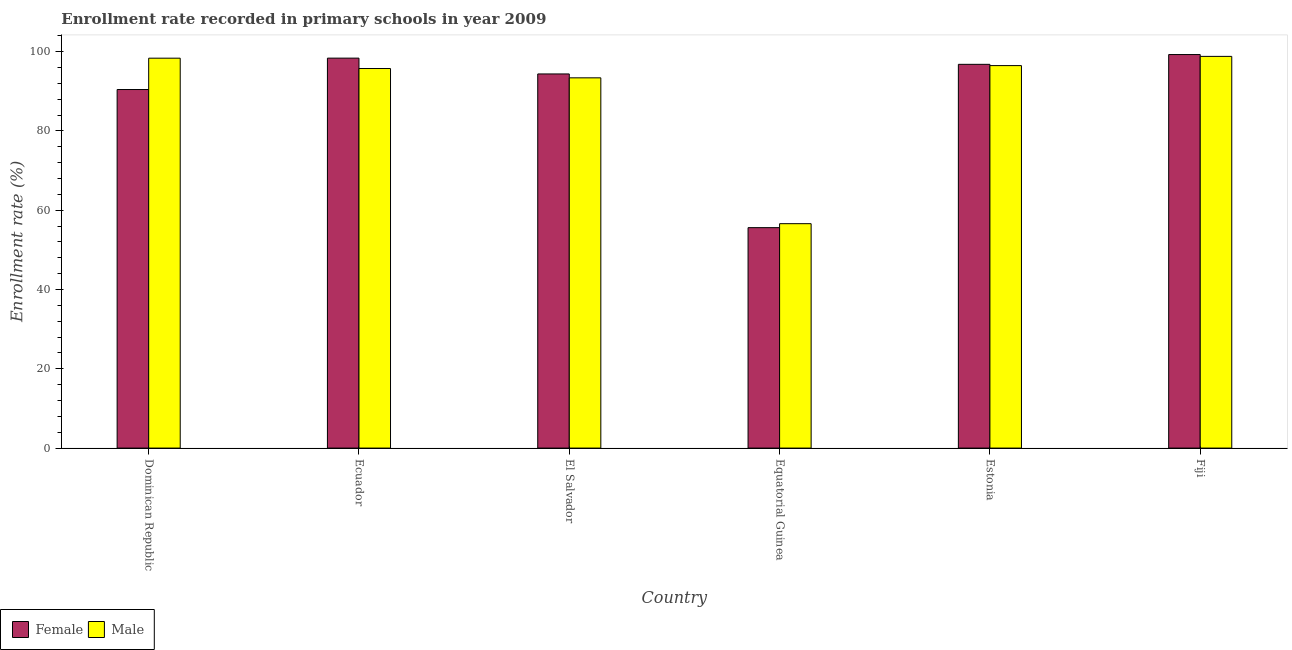How many different coloured bars are there?
Give a very brief answer. 2. How many bars are there on the 4th tick from the right?
Your answer should be compact. 2. What is the label of the 4th group of bars from the left?
Keep it short and to the point. Equatorial Guinea. What is the enrollment rate of male students in Dominican Republic?
Ensure brevity in your answer.  98.36. Across all countries, what is the maximum enrollment rate of male students?
Provide a succinct answer. 98.82. Across all countries, what is the minimum enrollment rate of female students?
Provide a short and direct response. 55.61. In which country was the enrollment rate of male students maximum?
Your response must be concise. Fiji. In which country was the enrollment rate of male students minimum?
Make the answer very short. Equatorial Guinea. What is the total enrollment rate of male students in the graph?
Give a very brief answer. 539.43. What is the difference between the enrollment rate of female students in Dominican Republic and that in Estonia?
Your response must be concise. -6.35. What is the difference between the enrollment rate of male students in El Salvador and the enrollment rate of female students in Dominican Republic?
Make the answer very short. 2.95. What is the average enrollment rate of male students per country?
Provide a succinct answer. 89.9. What is the difference between the enrollment rate of female students and enrollment rate of male students in El Salvador?
Offer a terse response. 0.98. What is the ratio of the enrollment rate of female students in Dominican Republic to that in Fiji?
Give a very brief answer. 0.91. Is the difference between the enrollment rate of female students in Ecuador and Fiji greater than the difference between the enrollment rate of male students in Ecuador and Fiji?
Your answer should be compact. Yes. What is the difference between the highest and the second highest enrollment rate of female students?
Offer a terse response. 0.9. What is the difference between the highest and the lowest enrollment rate of male students?
Your answer should be compact. 42.2. Is the sum of the enrollment rate of male students in Ecuador and Estonia greater than the maximum enrollment rate of female students across all countries?
Your response must be concise. Yes. What does the 1st bar from the left in Ecuador represents?
Your answer should be compact. Female. What does the 1st bar from the right in Estonia represents?
Your answer should be very brief. Male. How many bars are there?
Your answer should be compact. 12. What is the difference between two consecutive major ticks on the Y-axis?
Your answer should be compact. 20. Does the graph contain grids?
Make the answer very short. No. How are the legend labels stacked?
Your answer should be compact. Horizontal. What is the title of the graph?
Ensure brevity in your answer.  Enrollment rate recorded in primary schools in year 2009. What is the label or title of the Y-axis?
Provide a short and direct response. Enrollment rate (%). What is the Enrollment rate (%) in Female in Dominican Republic?
Offer a very short reply. 90.45. What is the Enrollment rate (%) in Male in Dominican Republic?
Make the answer very short. 98.36. What is the Enrollment rate (%) of Female in Ecuador?
Your answer should be compact. 98.37. What is the Enrollment rate (%) of Male in Ecuador?
Keep it short and to the point. 95.75. What is the Enrollment rate (%) of Female in El Salvador?
Give a very brief answer. 94.38. What is the Enrollment rate (%) of Male in El Salvador?
Offer a very short reply. 93.4. What is the Enrollment rate (%) in Female in Equatorial Guinea?
Keep it short and to the point. 55.61. What is the Enrollment rate (%) in Male in Equatorial Guinea?
Provide a short and direct response. 56.61. What is the Enrollment rate (%) of Female in Estonia?
Keep it short and to the point. 96.81. What is the Enrollment rate (%) of Male in Estonia?
Provide a succinct answer. 96.49. What is the Enrollment rate (%) of Female in Fiji?
Offer a terse response. 99.28. What is the Enrollment rate (%) of Male in Fiji?
Your answer should be compact. 98.82. Across all countries, what is the maximum Enrollment rate (%) in Female?
Your answer should be compact. 99.28. Across all countries, what is the maximum Enrollment rate (%) in Male?
Keep it short and to the point. 98.82. Across all countries, what is the minimum Enrollment rate (%) in Female?
Offer a terse response. 55.61. Across all countries, what is the minimum Enrollment rate (%) in Male?
Make the answer very short. 56.61. What is the total Enrollment rate (%) of Female in the graph?
Offer a very short reply. 534.9. What is the total Enrollment rate (%) in Male in the graph?
Provide a succinct answer. 539.43. What is the difference between the Enrollment rate (%) of Female in Dominican Republic and that in Ecuador?
Give a very brief answer. -7.92. What is the difference between the Enrollment rate (%) of Male in Dominican Republic and that in Ecuador?
Your response must be concise. 2.61. What is the difference between the Enrollment rate (%) in Female in Dominican Republic and that in El Salvador?
Give a very brief answer. -3.93. What is the difference between the Enrollment rate (%) in Male in Dominican Republic and that in El Salvador?
Give a very brief answer. 4.96. What is the difference between the Enrollment rate (%) of Female in Dominican Republic and that in Equatorial Guinea?
Provide a short and direct response. 34.85. What is the difference between the Enrollment rate (%) in Male in Dominican Republic and that in Equatorial Guinea?
Your response must be concise. 41.75. What is the difference between the Enrollment rate (%) in Female in Dominican Republic and that in Estonia?
Your answer should be very brief. -6.35. What is the difference between the Enrollment rate (%) of Male in Dominican Republic and that in Estonia?
Ensure brevity in your answer.  1.87. What is the difference between the Enrollment rate (%) in Female in Dominican Republic and that in Fiji?
Provide a short and direct response. -8.82. What is the difference between the Enrollment rate (%) in Male in Dominican Republic and that in Fiji?
Offer a very short reply. -0.46. What is the difference between the Enrollment rate (%) in Female in Ecuador and that in El Salvador?
Offer a very short reply. 3.99. What is the difference between the Enrollment rate (%) of Male in Ecuador and that in El Salvador?
Provide a short and direct response. 2.35. What is the difference between the Enrollment rate (%) in Female in Ecuador and that in Equatorial Guinea?
Keep it short and to the point. 42.76. What is the difference between the Enrollment rate (%) in Male in Ecuador and that in Equatorial Guinea?
Offer a terse response. 39.14. What is the difference between the Enrollment rate (%) in Female in Ecuador and that in Estonia?
Keep it short and to the point. 1.56. What is the difference between the Enrollment rate (%) in Male in Ecuador and that in Estonia?
Make the answer very short. -0.74. What is the difference between the Enrollment rate (%) of Female in Ecuador and that in Fiji?
Your answer should be very brief. -0.9. What is the difference between the Enrollment rate (%) in Male in Ecuador and that in Fiji?
Ensure brevity in your answer.  -3.07. What is the difference between the Enrollment rate (%) of Female in El Salvador and that in Equatorial Guinea?
Your response must be concise. 38.77. What is the difference between the Enrollment rate (%) in Male in El Salvador and that in Equatorial Guinea?
Offer a terse response. 36.79. What is the difference between the Enrollment rate (%) in Female in El Salvador and that in Estonia?
Keep it short and to the point. -2.42. What is the difference between the Enrollment rate (%) in Male in El Salvador and that in Estonia?
Offer a terse response. -3.09. What is the difference between the Enrollment rate (%) in Female in El Salvador and that in Fiji?
Your response must be concise. -4.89. What is the difference between the Enrollment rate (%) of Male in El Salvador and that in Fiji?
Offer a very short reply. -5.42. What is the difference between the Enrollment rate (%) in Female in Equatorial Guinea and that in Estonia?
Give a very brief answer. -41.2. What is the difference between the Enrollment rate (%) of Male in Equatorial Guinea and that in Estonia?
Keep it short and to the point. -39.88. What is the difference between the Enrollment rate (%) of Female in Equatorial Guinea and that in Fiji?
Provide a short and direct response. -43.67. What is the difference between the Enrollment rate (%) in Male in Equatorial Guinea and that in Fiji?
Provide a succinct answer. -42.2. What is the difference between the Enrollment rate (%) in Female in Estonia and that in Fiji?
Ensure brevity in your answer.  -2.47. What is the difference between the Enrollment rate (%) in Male in Estonia and that in Fiji?
Give a very brief answer. -2.33. What is the difference between the Enrollment rate (%) of Female in Dominican Republic and the Enrollment rate (%) of Male in Ecuador?
Your answer should be very brief. -5.3. What is the difference between the Enrollment rate (%) in Female in Dominican Republic and the Enrollment rate (%) in Male in El Salvador?
Offer a terse response. -2.95. What is the difference between the Enrollment rate (%) in Female in Dominican Republic and the Enrollment rate (%) in Male in Equatorial Guinea?
Your answer should be very brief. 33.84. What is the difference between the Enrollment rate (%) of Female in Dominican Republic and the Enrollment rate (%) of Male in Estonia?
Your response must be concise. -6.04. What is the difference between the Enrollment rate (%) in Female in Dominican Republic and the Enrollment rate (%) in Male in Fiji?
Ensure brevity in your answer.  -8.36. What is the difference between the Enrollment rate (%) of Female in Ecuador and the Enrollment rate (%) of Male in El Salvador?
Keep it short and to the point. 4.97. What is the difference between the Enrollment rate (%) in Female in Ecuador and the Enrollment rate (%) in Male in Equatorial Guinea?
Your answer should be very brief. 41.76. What is the difference between the Enrollment rate (%) of Female in Ecuador and the Enrollment rate (%) of Male in Estonia?
Your answer should be compact. 1.88. What is the difference between the Enrollment rate (%) in Female in Ecuador and the Enrollment rate (%) in Male in Fiji?
Offer a terse response. -0.44. What is the difference between the Enrollment rate (%) in Female in El Salvador and the Enrollment rate (%) in Male in Equatorial Guinea?
Offer a very short reply. 37.77. What is the difference between the Enrollment rate (%) of Female in El Salvador and the Enrollment rate (%) of Male in Estonia?
Your answer should be very brief. -2.11. What is the difference between the Enrollment rate (%) of Female in El Salvador and the Enrollment rate (%) of Male in Fiji?
Offer a very short reply. -4.43. What is the difference between the Enrollment rate (%) of Female in Equatorial Guinea and the Enrollment rate (%) of Male in Estonia?
Offer a terse response. -40.88. What is the difference between the Enrollment rate (%) in Female in Equatorial Guinea and the Enrollment rate (%) in Male in Fiji?
Offer a terse response. -43.21. What is the difference between the Enrollment rate (%) in Female in Estonia and the Enrollment rate (%) in Male in Fiji?
Provide a short and direct response. -2.01. What is the average Enrollment rate (%) in Female per country?
Offer a very short reply. 89.15. What is the average Enrollment rate (%) of Male per country?
Provide a short and direct response. 89.9. What is the difference between the Enrollment rate (%) of Female and Enrollment rate (%) of Male in Dominican Republic?
Your response must be concise. -7.91. What is the difference between the Enrollment rate (%) in Female and Enrollment rate (%) in Male in Ecuador?
Ensure brevity in your answer.  2.62. What is the difference between the Enrollment rate (%) in Female and Enrollment rate (%) in Male in El Salvador?
Keep it short and to the point. 0.98. What is the difference between the Enrollment rate (%) of Female and Enrollment rate (%) of Male in Equatorial Guinea?
Ensure brevity in your answer.  -1. What is the difference between the Enrollment rate (%) in Female and Enrollment rate (%) in Male in Estonia?
Provide a succinct answer. 0.32. What is the difference between the Enrollment rate (%) in Female and Enrollment rate (%) in Male in Fiji?
Your response must be concise. 0.46. What is the ratio of the Enrollment rate (%) of Female in Dominican Republic to that in Ecuador?
Offer a terse response. 0.92. What is the ratio of the Enrollment rate (%) in Male in Dominican Republic to that in Ecuador?
Provide a succinct answer. 1.03. What is the ratio of the Enrollment rate (%) in Female in Dominican Republic to that in El Salvador?
Provide a succinct answer. 0.96. What is the ratio of the Enrollment rate (%) of Male in Dominican Republic to that in El Salvador?
Provide a succinct answer. 1.05. What is the ratio of the Enrollment rate (%) of Female in Dominican Republic to that in Equatorial Guinea?
Ensure brevity in your answer.  1.63. What is the ratio of the Enrollment rate (%) of Male in Dominican Republic to that in Equatorial Guinea?
Keep it short and to the point. 1.74. What is the ratio of the Enrollment rate (%) in Female in Dominican Republic to that in Estonia?
Make the answer very short. 0.93. What is the ratio of the Enrollment rate (%) of Male in Dominican Republic to that in Estonia?
Offer a terse response. 1.02. What is the ratio of the Enrollment rate (%) of Female in Dominican Republic to that in Fiji?
Your response must be concise. 0.91. What is the ratio of the Enrollment rate (%) in Male in Dominican Republic to that in Fiji?
Provide a succinct answer. 1. What is the ratio of the Enrollment rate (%) of Female in Ecuador to that in El Salvador?
Offer a very short reply. 1.04. What is the ratio of the Enrollment rate (%) in Male in Ecuador to that in El Salvador?
Make the answer very short. 1.03. What is the ratio of the Enrollment rate (%) of Female in Ecuador to that in Equatorial Guinea?
Keep it short and to the point. 1.77. What is the ratio of the Enrollment rate (%) in Male in Ecuador to that in Equatorial Guinea?
Give a very brief answer. 1.69. What is the ratio of the Enrollment rate (%) of Female in Ecuador to that in Estonia?
Offer a very short reply. 1.02. What is the ratio of the Enrollment rate (%) of Female in Ecuador to that in Fiji?
Provide a short and direct response. 0.99. What is the ratio of the Enrollment rate (%) of Male in Ecuador to that in Fiji?
Provide a succinct answer. 0.97. What is the ratio of the Enrollment rate (%) in Female in El Salvador to that in Equatorial Guinea?
Ensure brevity in your answer.  1.7. What is the ratio of the Enrollment rate (%) of Male in El Salvador to that in Equatorial Guinea?
Keep it short and to the point. 1.65. What is the ratio of the Enrollment rate (%) of Female in El Salvador to that in Estonia?
Make the answer very short. 0.97. What is the ratio of the Enrollment rate (%) in Male in El Salvador to that in Estonia?
Offer a terse response. 0.97. What is the ratio of the Enrollment rate (%) of Female in El Salvador to that in Fiji?
Provide a short and direct response. 0.95. What is the ratio of the Enrollment rate (%) in Male in El Salvador to that in Fiji?
Provide a succinct answer. 0.95. What is the ratio of the Enrollment rate (%) in Female in Equatorial Guinea to that in Estonia?
Your response must be concise. 0.57. What is the ratio of the Enrollment rate (%) in Male in Equatorial Guinea to that in Estonia?
Make the answer very short. 0.59. What is the ratio of the Enrollment rate (%) of Female in Equatorial Guinea to that in Fiji?
Offer a terse response. 0.56. What is the ratio of the Enrollment rate (%) of Male in Equatorial Guinea to that in Fiji?
Provide a succinct answer. 0.57. What is the ratio of the Enrollment rate (%) of Female in Estonia to that in Fiji?
Offer a terse response. 0.98. What is the ratio of the Enrollment rate (%) of Male in Estonia to that in Fiji?
Your answer should be compact. 0.98. What is the difference between the highest and the second highest Enrollment rate (%) of Female?
Your answer should be very brief. 0.9. What is the difference between the highest and the second highest Enrollment rate (%) in Male?
Your response must be concise. 0.46. What is the difference between the highest and the lowest Enrollment rate (%) in Female?
Provide a succinct answer. 43.67. What is the difference between the highest and the lowest Enrollment rate (%) of Male?
Ensure brevity in your answer.  42.2. 